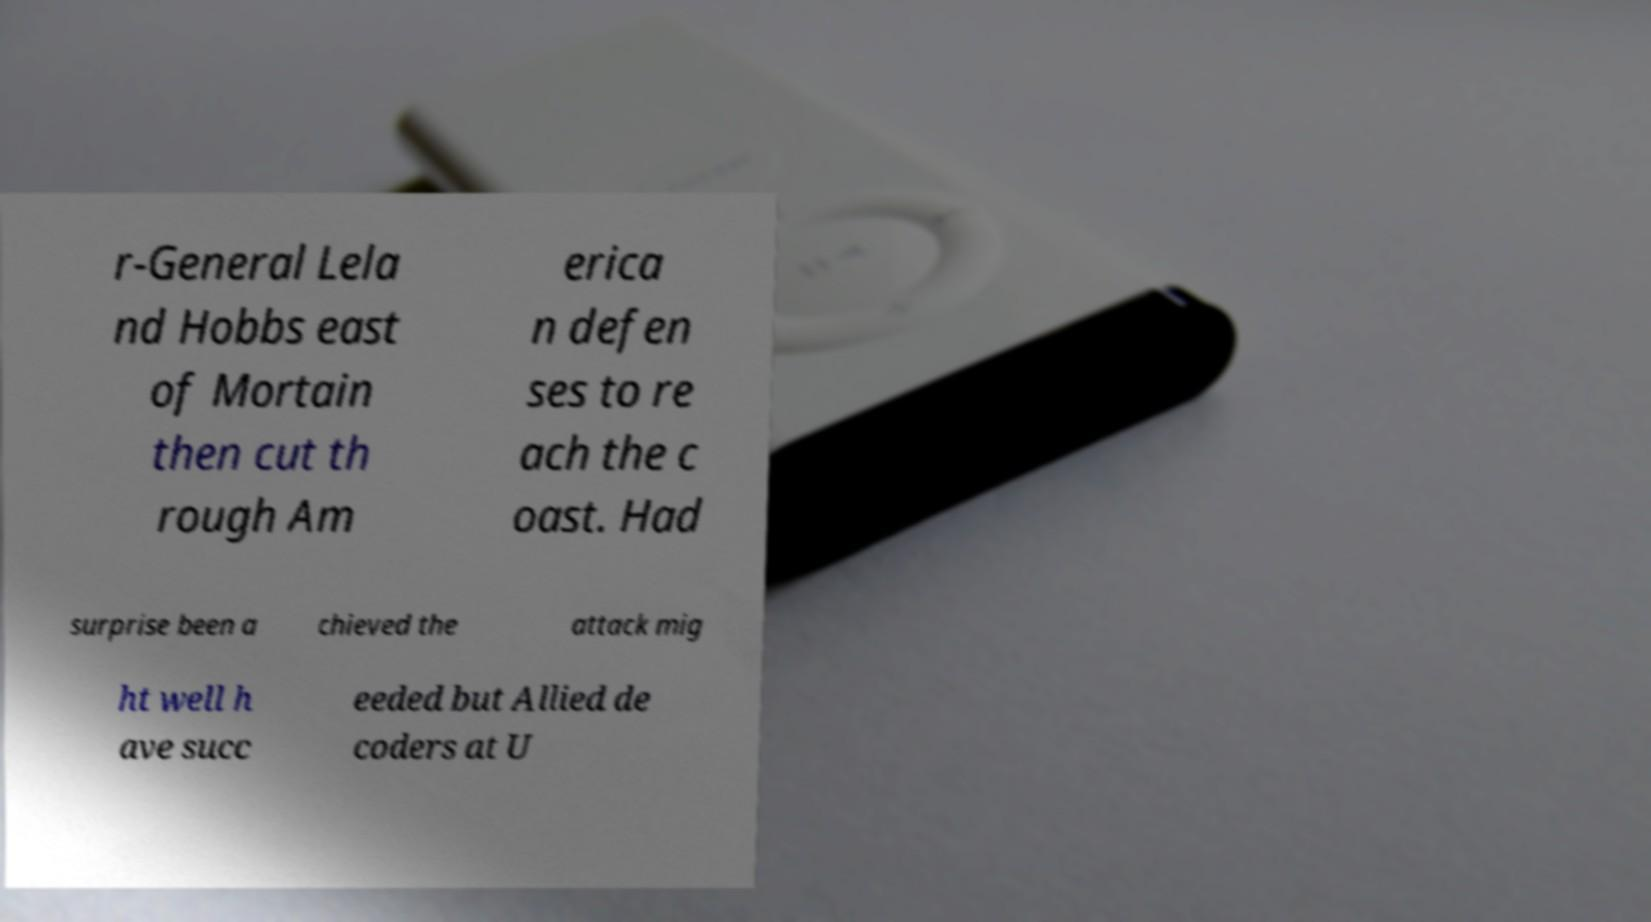For documentation purposes, I need the text within this image transcribed. Could you provide that? r-General Lela nd Hobbs east of Mortain then cut th rough Am erica n defen ses to re ach the c oast. Had surprise been a chieved the attack mig ht well h ave succ eeded but Allied de coders at U 